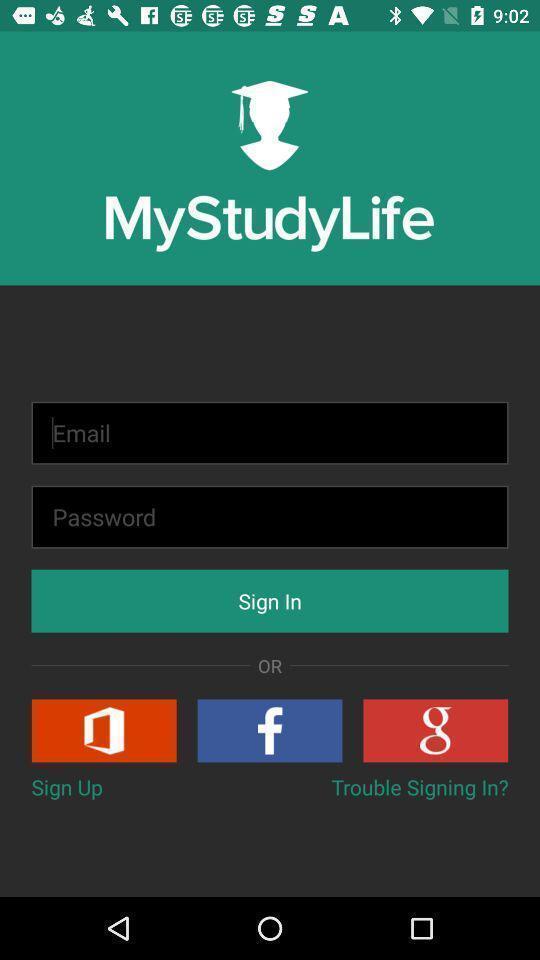Give me a summary of this screen capture. Sign up page of a study app. 